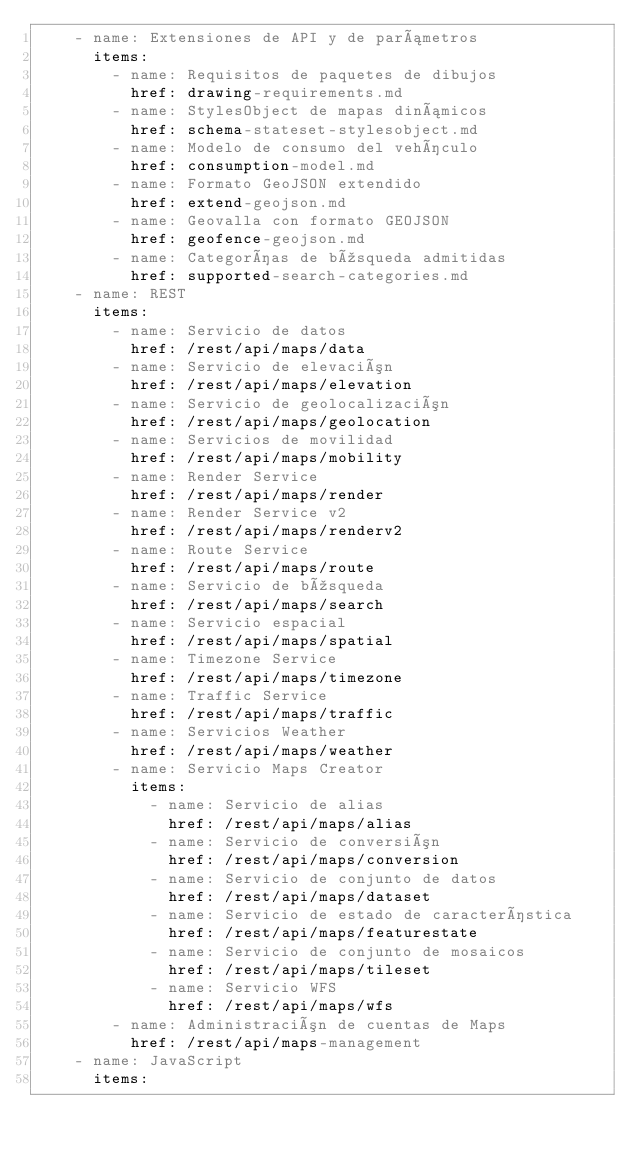<code> <loc_0><loc_0><loc_500><loc_500><_YAML_>    - name: Extensiones de API y de parámetros
      items:
        - name: Requisitos de paquetes de dibujos
          href: drawing-requirements.md
        - name: StylesObject de mapas dinámicos
          href: schema-stateset-stylesobject.md
        - name: Modelo de consumo del vehículo
          href: consumption-model.md
        - name: Formato GeoJSON extendido
          href: extend-geojson.md
        - name: Geovalla con formato GEOJSON
          href: geofence-geojson.md
        - name: Categorías de búsqueda admitidas
          href: supported-search-categories.md
    - name: REST
      items:
        - name: Servicio de datos
          href: /rest/api/maps/data
        - name: Servicio de elevación
          href: /rest/api/maps/elevation
        - name: Servicio de geolocalización
          href: /rest/api/maps/geolocation
        - name: Servicios de movilidad
          href: /rest/api/maps/mobility
        - name: Render Service
          href: /rest/api/maps/render
        - name: Render Service v2
          href: /rest/api/maps/renderv2
        - name: Route Service
          href: /rest/api/maps/route
        - name: Servicio de búsqueda
          href: /rest/api/maps/search
        - name: Servicio espacial
          href: /rest/api/maps/spatial
        - name: Timezone Service
          href: /rest/api/maps/timezone
        - name: Traffic Service
          href: /rest/api/maps/traffic
        - name: Servicios Weather
          href: /rest/api/maps/weather
        - name: Servicio Maps Creator
          items:
            - name: Servicio de alias
              href: /rest/api/maps/alias
            - name: Servicio de conversión
              href: /rest/api/maps/conversion
            - name: Servicio de conjunto de datos
              href: /rest/api/maps/dataset
            - name: Servicio de estado de característica
              href: /rest/api/maps/featurestate
            - name: Servicio de conjunto de mosaicos
              href: /rest/api/maps/tileset
            - name: Servicio WFS
              href: /rest/api/maps/wfs
        - name: Administración de cuentas de Maps
          href: /rest/api/maps-management
    - name: JavaScript
      items:</code> 